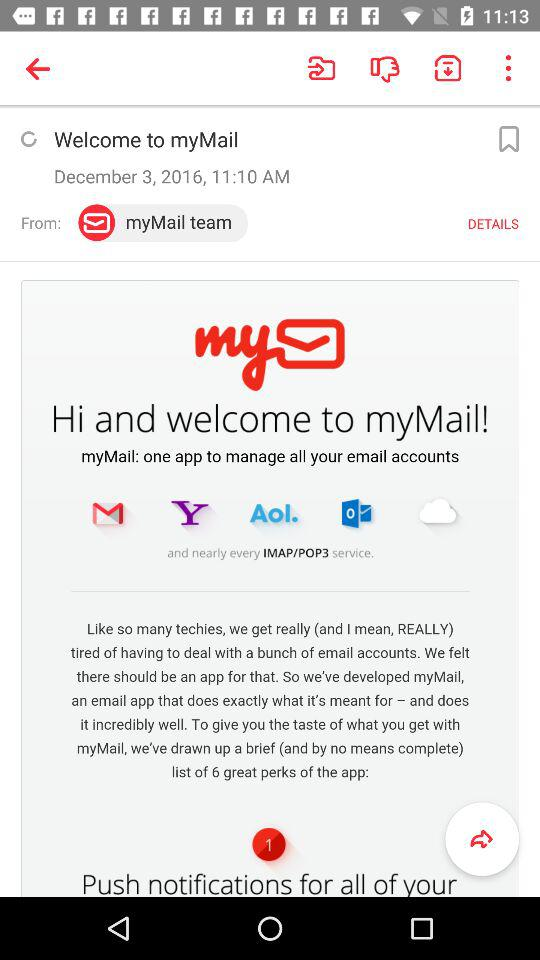What is the mentioned time? The mentioned time is 11:10 a.m. 